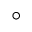Convert formula to latex. <formula><loc_0><loc_0><loc_500><loc_500>^ { \circ }</formula> 